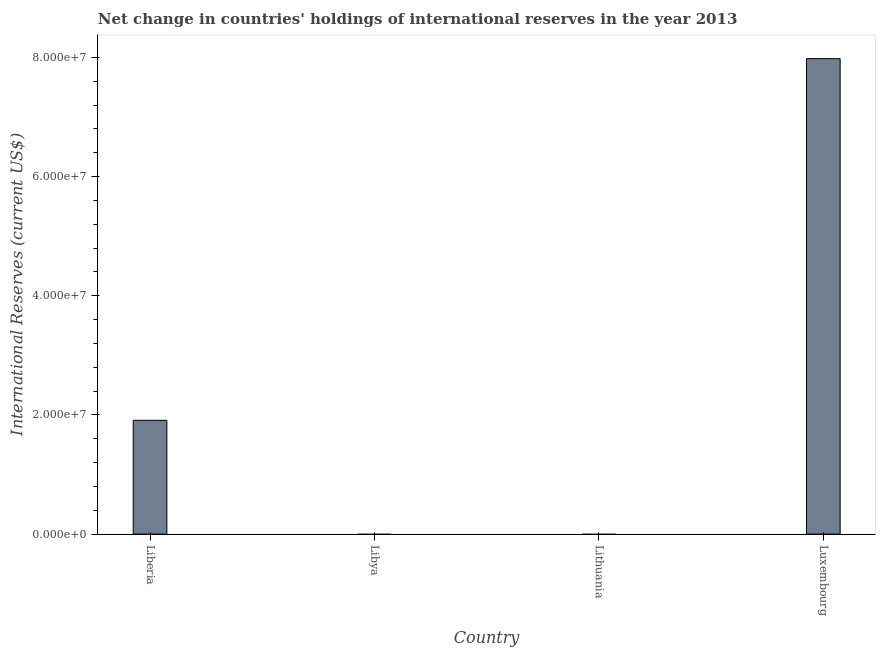Does the graph contain grids?
Make the answer very short. No. What is the title of the graph?
Make the answer very short. Net change in countries' holdings of international reserves in the year 2013. What is the label or title of the X-axis?
Your answer should be compact. Country. What is the label or title of the Y-axis?
Offer a very short reply. International Reserves (current US$). What is the reserves and related items in Liberia?
Offer a terse response. 1.91e+07. Across all countries, what is the maximum reserves and related items?
Make the answer very short. 7.98e+07. Across all countries, what is the minimum reserves and related items?
Provide a succinct answer. 0. In which country was the reserves and related items maximum?
Offer a very short reply. Luxembourg. What is the sum of the reserves and related items?
Provide a succinct answer. 9.89e+07. What is the difference between the reserves and related items in Liberia and Luxembourg?
Offer a terse response. -6.07e+07. What is the average reserves and related items per country?
Your response must be concise. 2.47e+07. What is the median reserves and related items?
Your answer should be very brief. 9.55e+06. Is the reserves and related items in Liberia less than that in Luxembourg?
Keep it short and to the point. Yes. What is the difference between the highest and the lowest reserves and related items?
Your response must be concise. 7.98e+07. How many bars are there?
Offer a very short reply. 2. Are all the bars in the graph horizontal?
Offer a very short reply. No. How many countries are there in the graph?
Keep it short and to the point. 4. Are the values on the major ticks of Y-axis written in scientific E-notation?
Your answer should be very brief. Yes. What is the International Reserves (current US$) in Liberia?
Your answer should be very brief. 1.91e+07. What is the International Reserves (current US$) in Libya?
Offer a terse response. 0. What is the International Reserves (current US$) of Lithuania?
Make the answer very short. 0. What is the International Reserves (current US$) of Luxembourg?
Offer a terse response. 7.98e+07. What is the difference between the International Reserves (current US$) in Liberia and Luxembourg?
Ensure brevity in your answer.  -6.07e+07. What is the ratio of the International Reserves (current US$) in Liberia to that in Luxembourg?
Ensure brevity in your answer.  0.24. 